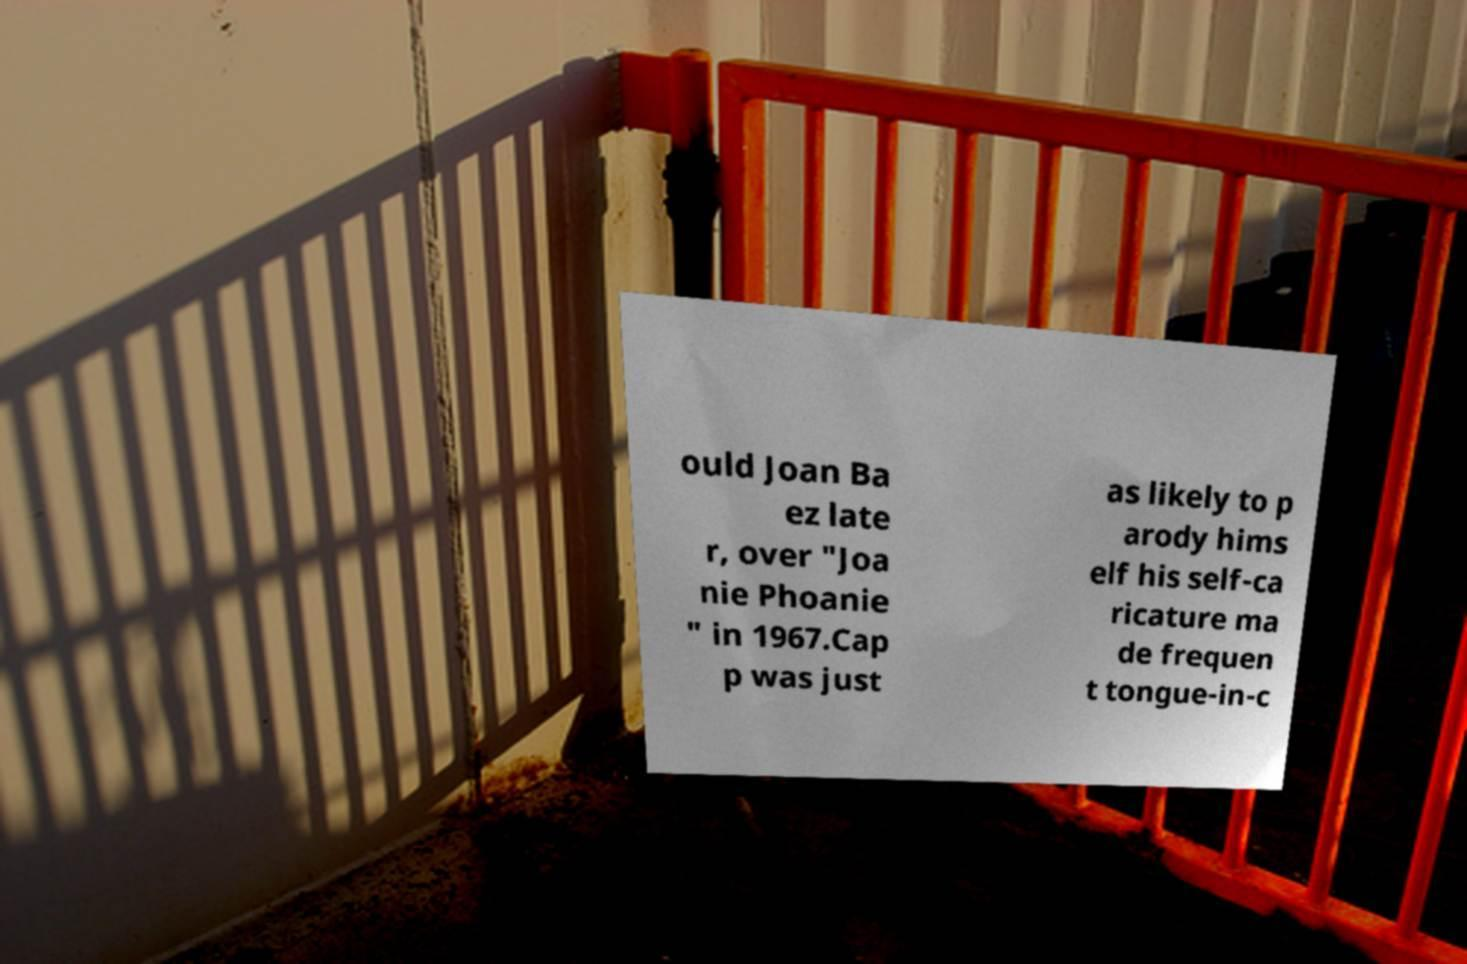Please read and relay the text visible in this image. What does it say? ould Joan Ba ez late r, over "Joa nie Phoanie " in 1967.Cap p was just as likely to p arody hims elf his self-ca ricature ma de frequen t tongue-in-c 